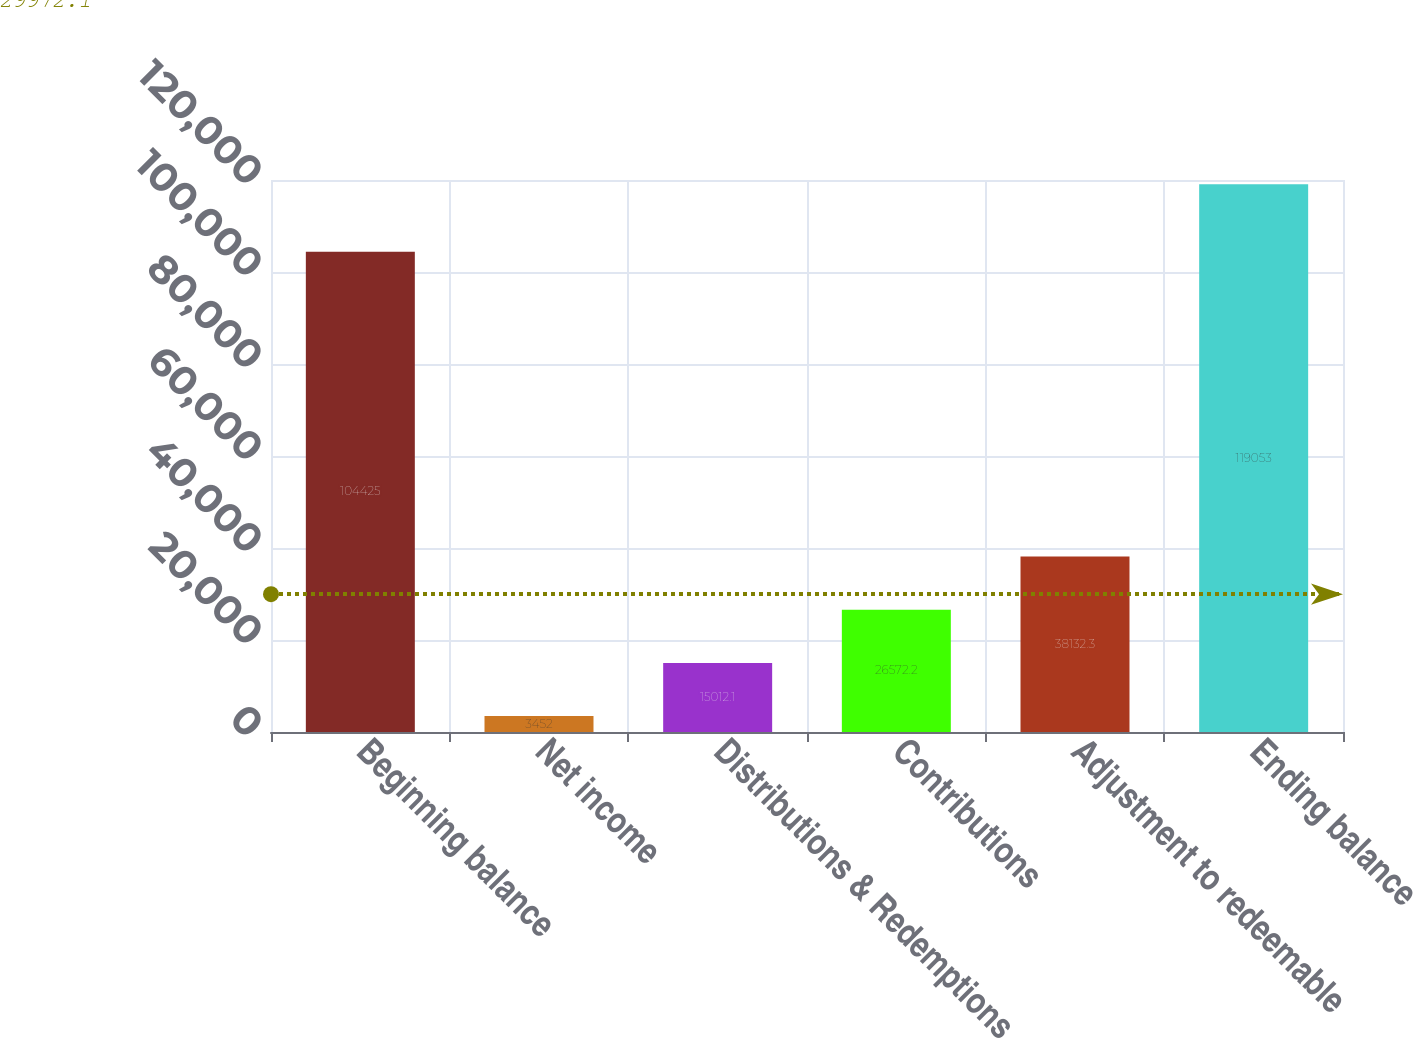<chart> <loc_0><loc_0><loc_500><loc_500><bar_chart><fcel>Beginning balance<fcel>Net income<fcel>Distributions & Redemptions<fcel>Contributions<fcel>Adjustment to redeemable<fcel>Ending balance<nl><fcel>104425<fcel>3452<fcel>15012.1<fcel>26572.2<fcel>38132.3<fcel>119053<nl></chart> 